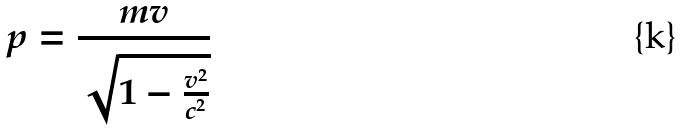<formula> <loc_0><loc_0><loc_500><loc_500>p = \frac { m v } { \sqrt { 1 - \frac { v ^ { 2 } } { c ^ { 2 } } } }</formula> 